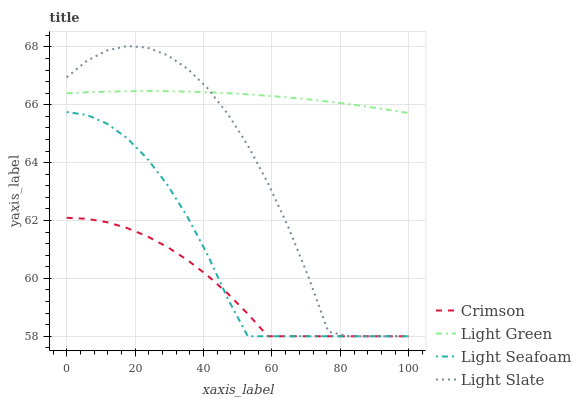Does Crimson have the minimum area under the curve?
Answer yes or no. Yes. Does Light Green have the maximum area under the curve?
Answer yes or no. Yes. Does Light Slate have the minimum area under the curve?
Answer yes or no. No. Does Light Slate have the maximum area under the curve?
Answer yes or no. No. Is Light Green the smoothest?
Answer yes or no. Yes. Is Light Slate the roughest?
Answer yes or no. Yes. Is Light Seafoam the smoothest?
Answer yes or no. No. Is Light Seafoam the roughest?
Answer yes or no. No. Does Crimson have the lowest value?
Answer yes or no. Yes. Does Light Green have the lowest value?
Answer yes or no. No. Does Light Slate have the highest value?
Answer yes or no. Yes. Does Light Seafoam have the highest value?
Answer yes or no. No. Is Crimson less than Light Green?
Answer yes or no. Yes. Is Light Green greater than Crimson?
Answer yes or no. Yes. Does Crimson intersect Light Seafoam?
Answer yes or no. Yes. Is Crimson less than Light Seafoam?
Answer yes or no. No. Is Crimson greater than Light Seafoam?
Answer yes or no. No. Does Crimson intersect Light Green?
Answer yes or no. No. 